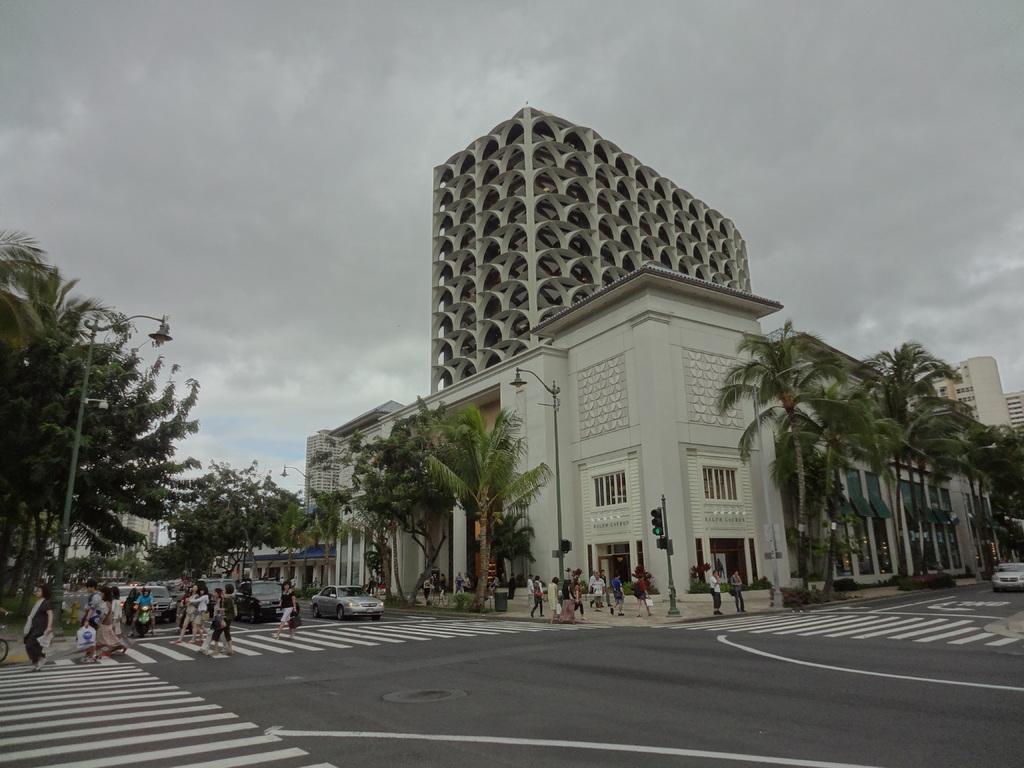Describe this image in one or two sentences. In this image there are buildings, in front of the buildings there is a road on which there are vehicles moving and people are walking on the road, there are trees, lamp and the sky. 